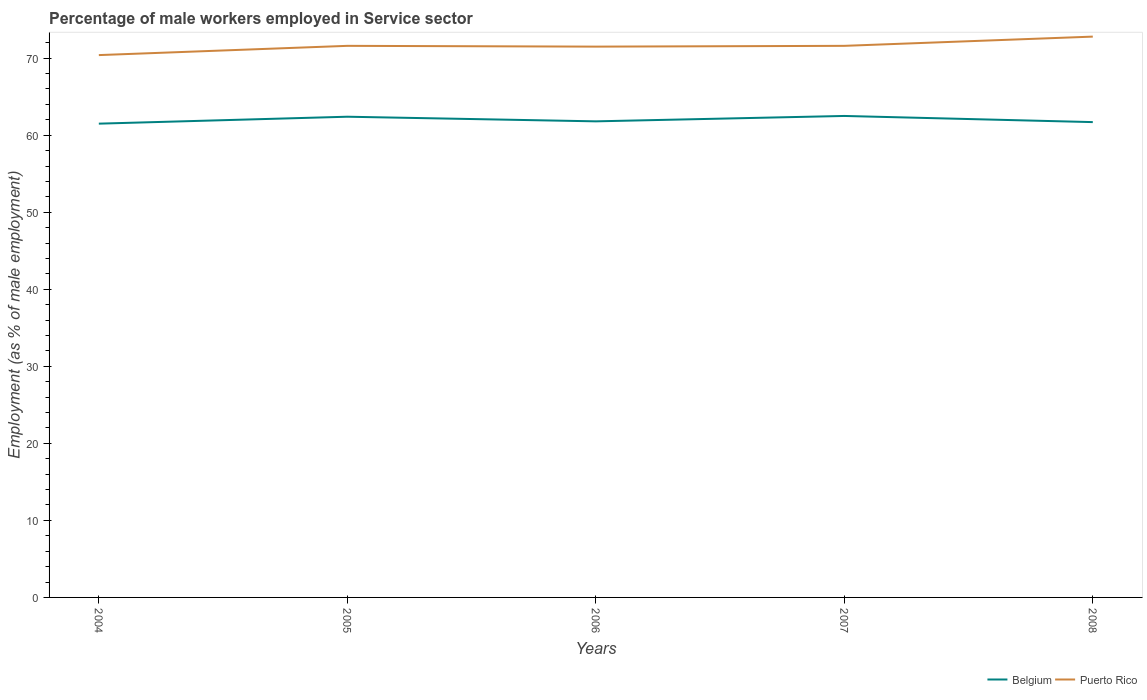Across all years, what is the maximum percentage of male workers employed in Service sector in Belgium?
Offer a very short reply. 61.5. In which year was the percentage of male workers employed in Service sector in Belgium maximum?
Keep it short and to the point. 2004. What is the total percentage of male workers employed in Service sector in Puerto Rico in the graph?
Make the answer very short. -1.2. What is the difference between the highest and the second highest percentage of male workers employed in Service sector in Puerto Rico?
Offer a terse response. 2.4. What is the difference between the highest and the lowest percentage of male workers employed in Service sector in Belgium?
Your answer should be very brief. 2. How many lines are there?
Provide a succinct answer. 2. How many years are there in the graph?
Make the answer very short. 5. What is the difference between two consecutive major ticks on the Y-axis?
Provide a short and direct response. 10. Where does the legend appear in the graph?
Your answer should be compact. Bottom right. How many legend labels are there?
Keep it short and to the point. 2. How are the legend labels stacked?
Provide a short and direct response. Horizontal. What is the title of the graph?
Ensure brevity in your answer.  Percentage of male workers employed in Service sector. Does "Chile" appear as one of the legend labels in the graph?
Your answer should be compact. No. What is the label or title of the Y-axis?
Your answer should be compact. Employment (as % of male employment). What is the Employment (as % of male employment) of Belgium in 2004?
Your response must be concise. 61.5. What is the Employment (as % of male employment) in Puerto Rico in 2004?
Your answer should be very brief. 70.4. What is the Employment (as % of male employment) in Belgium in 2005?
Keep it short and to the point. 62.4. What is the Employment (as % of male employment) in Puerto Rico in 2005?
Make the answer very short. 71.6. What is the Employment (as % of male employment) in Belgium in 2006?
Offer a terse response. 61.8. What is the Employment (as % of male employment) in Puerto Rico in 2006?
Your answer should be compact. 71.5. What is the Employment (as % of male employment) in Belgium in 2007?
Make the answer very short. 62.5. What is the Employment (as % of male employment) of Puerto Rico in 2007?
Offer a terse response. 71.6. What is the Employment (as % of male employment) in Belgium in 2008?
Your answer should be compact. 61.7. What is the Employment (as % of male employment) in Puerto Rico in 2008?
Your response must be concise. 72.8. Across all years, what is the maximum Employment (as % of male employment) in Belgium?
Ensure brevity in your answer.  62.5. Across all years, what is the maximum Employment (as % of male employment) of Puerto Rico?
Offer a terse response. 72.8. Across all years, what is the minimum Employment (as % of male employment) in Belgium?
Give a very brief answer. 61.5. Across all years, what is the minimum Employment (as % of male employment) in Puerto Rico?
Offer a terse response. 70.4. What is the total Employment (as % of male employment) of Belgium in the graph?
Ensure brevity in your answer.  309.9. What is the total Employment (as % of male employment) of Puerto Rico in the graph?
Offer a terse response. 357.9. What is the difference between the Employment (as % of male employment) in Belgium in 2004 and that in 2005?
Your response must be concise. -0.9. What is the difference between the Employment (as % of male employment) of Puerto Rico in 2004 and that in 2005?
Provide a succinct answer. -1.2. What is the difference between the Employment (as % of male employment) in Puerto Rico in 2004 and that in 2007?
Provide a succinct answer. -1.2. What is the difference between the Employment (as % of male employment) of Belgium in 2004 and that in 2008?
Offer a very short reply. -0.2. What is the difference between the Employment (as % of male employment) in Puerto Rico in 2005 and that in 2006?
Make the answer very short. 0.1. What is the difference between the Employment (as % of male employment) of Belgium in 2005 and that in 2008?
Make the answer very short. 0.7. What is the difference between the Employment (as % of male employment) of Puerto Rico in 2006 and that in 2007?
Keep it short and to the point. -0.1. What is the difference between the Employment (as % of male employment) in Puerto Rico in 2006 and that in 2008?
Your response must be concise. -1.3. What is the difference between the Employment (as % of male employment) in Belgium in 2007 and that in 2008?
Your response must be concise. 0.8. What is the difference between the Employment (as % of male employment) of Belgium in 2004 and the Employment (as % of male employment) of Puerto Rico in 2006?
Keep it short and to the point. -10. What is the difference between the Employment (as % of male employment) in Belgium in 2004 and the Employment (as % of male employment) in Puerto Rico in 2007?
Keep it short and to the point. -10.1. What is the difference between the Employment (as % of male employment) in Belgium in 2005 and the Employment (as % of male employment) in Puerto Rico in 2008?
Provide a short and direct response. -10.4. What is the difference between the Employment (as % of male employment) in Belgium in 2006 and the Employment (as % of male employment) in Puerto Rico in 2008?
Offer a very short reply. -11. What is the difference between the Employment (as % of male employment) of Belgium in 2007 and the Employment (as % of male employment) of Puerto Rico in 2008?
Ensure brevity in your answer.  -10.3. What is the average Employment (as % of male employment) in Belgium per year?
Your answer should be compact. 61.98. What is the average Employment (as % of male employment) of Puerto Rico per year?
Ensure brevity in your answer.  71.58. In the year 2005, what is the difference between the Employment (as % of male employment) of Belgium and Employment (as % of male employment) of Puerto Rico?
Your answer should be compact. -9.2. In the year 2006, what is the difference between the Employment (as % of male employment) in Belgium and Employment (as % of male employment) in Puerto Rico?
Your answer should be compact. -9.7. What is the ratio of the Employment (as % of male employment) of Belgium in 2004 to that in 2005?
Give a very brief answer. 0.99. What is the ratio of the Employment (as % of male employment) in Puerto Rico in 2004 to that in 2005?
Offer a terse response. 0.98. What is the ratio of the Employment (as % of male employment) in Belgium in 2004 to that in 2006?
Provide a succinct answer. 1. What is the ratio of the Employment (as % of male employment) of Puerto Rico in 2004 to that in 2006?
Provide a succinct answer. 0.98. What is the ratio of the Employment (as % of male employment) in Belgium in 2004 to that in 2007?
Your answer should be compact. 0.98. What is the ratio of the Employment (as % of male employment) in Puerto Rico in 2004 to that in 2007?
Provide a short and direct response. 0.98. What is the ratio of the Employment (as % of male employment) in Puerto Rico in 2004 to that in 2008?
Ensure brevity in your answer.  0.97. What is the ratio of the Employment (as % of male employment) of Belgium in 2005 to that in 2006?
Your answer should be compact. 1.01. What is the ratio of the Employment (as % of male employment) of Belgium in 2005 to that in 2008?
Ensure brevity in your answer.  1.01. What is the ratio of the Employment (as % of male employment) in Puerto Rico in 2005 to that in 2008?
Your answer should be very brief. 0.98. What is the ratio of the Employment (as % of male employment) of Puerto Rico in 2006 to that in 2008?
Your response must be concise. 0.98. What is the ratio of the Employment (as % of male employment) of Puerto Rico in 2007 to that in 2008?
Offer a terse response. 0.98. What is the difference between the highest and the second highest Employment (as % of male employment) of Belgium?
Make the answer very short. 0.1. What is the difference between the highest and the lowest Employment (as % of male employment) in Puerto Rico?
Provide a succinct answer. 2.4. 